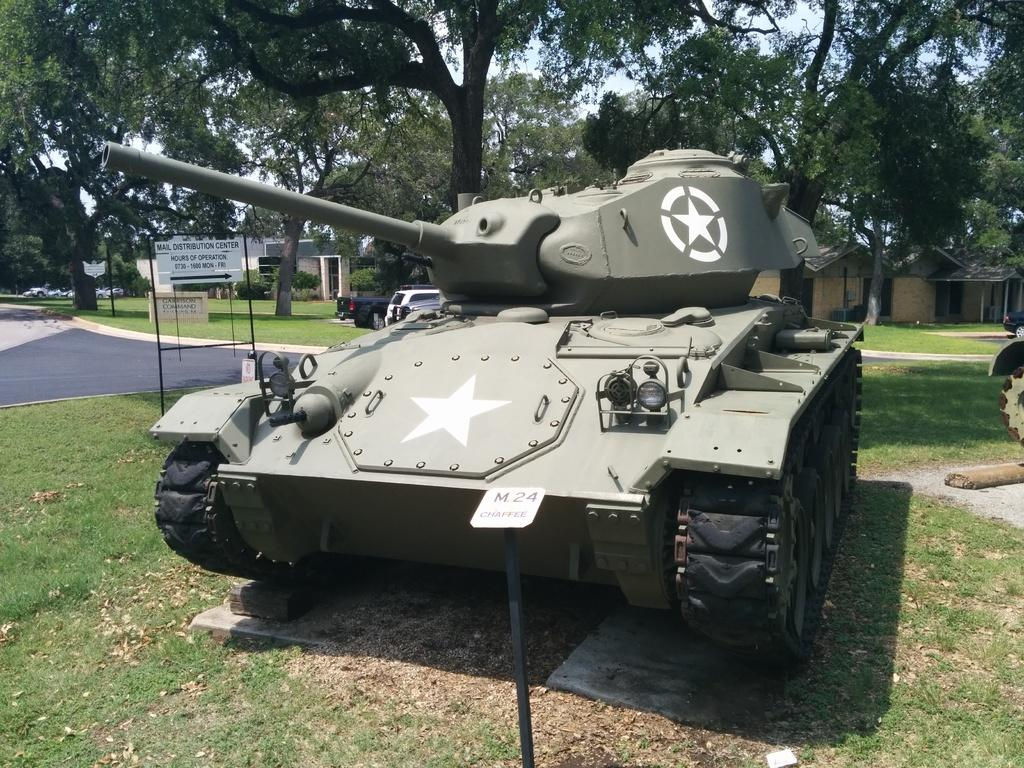What type of vehicle is in the image? There is an army bulldozer in the image. What type of signs can be seen in the image? There are name boards and sign boards in the image. What type of structures are visible in the image? There are buildings visible in the image. What type of vegetation is present in the image? Trees, plants, and grass are present in the image. What else is visible in the image besides the bulldozer and vegetation? Vehicles are visible in the image. What can be seen in the background of the image? The sky is visible in the background of the image. How much money is being exchanged between the vehicles in the image? There is no indication of money being exchanged in the image; it features an army bulldozer, signs, buildings, vegetation, and vehicles. What type of frame surrounds the image? The image does not have a frame; it is a digital representation of the scene. 